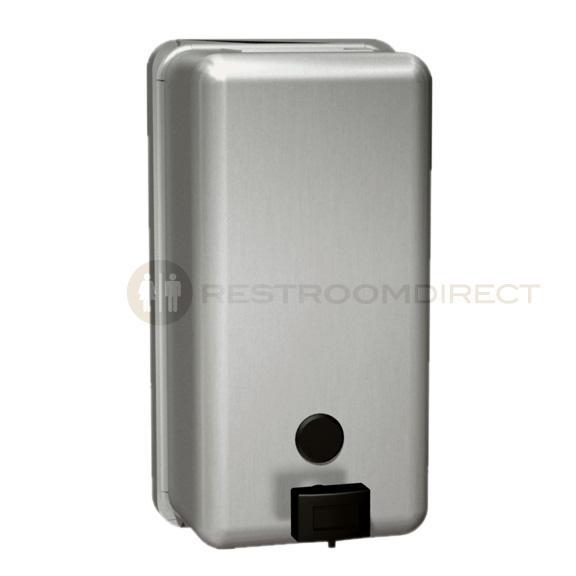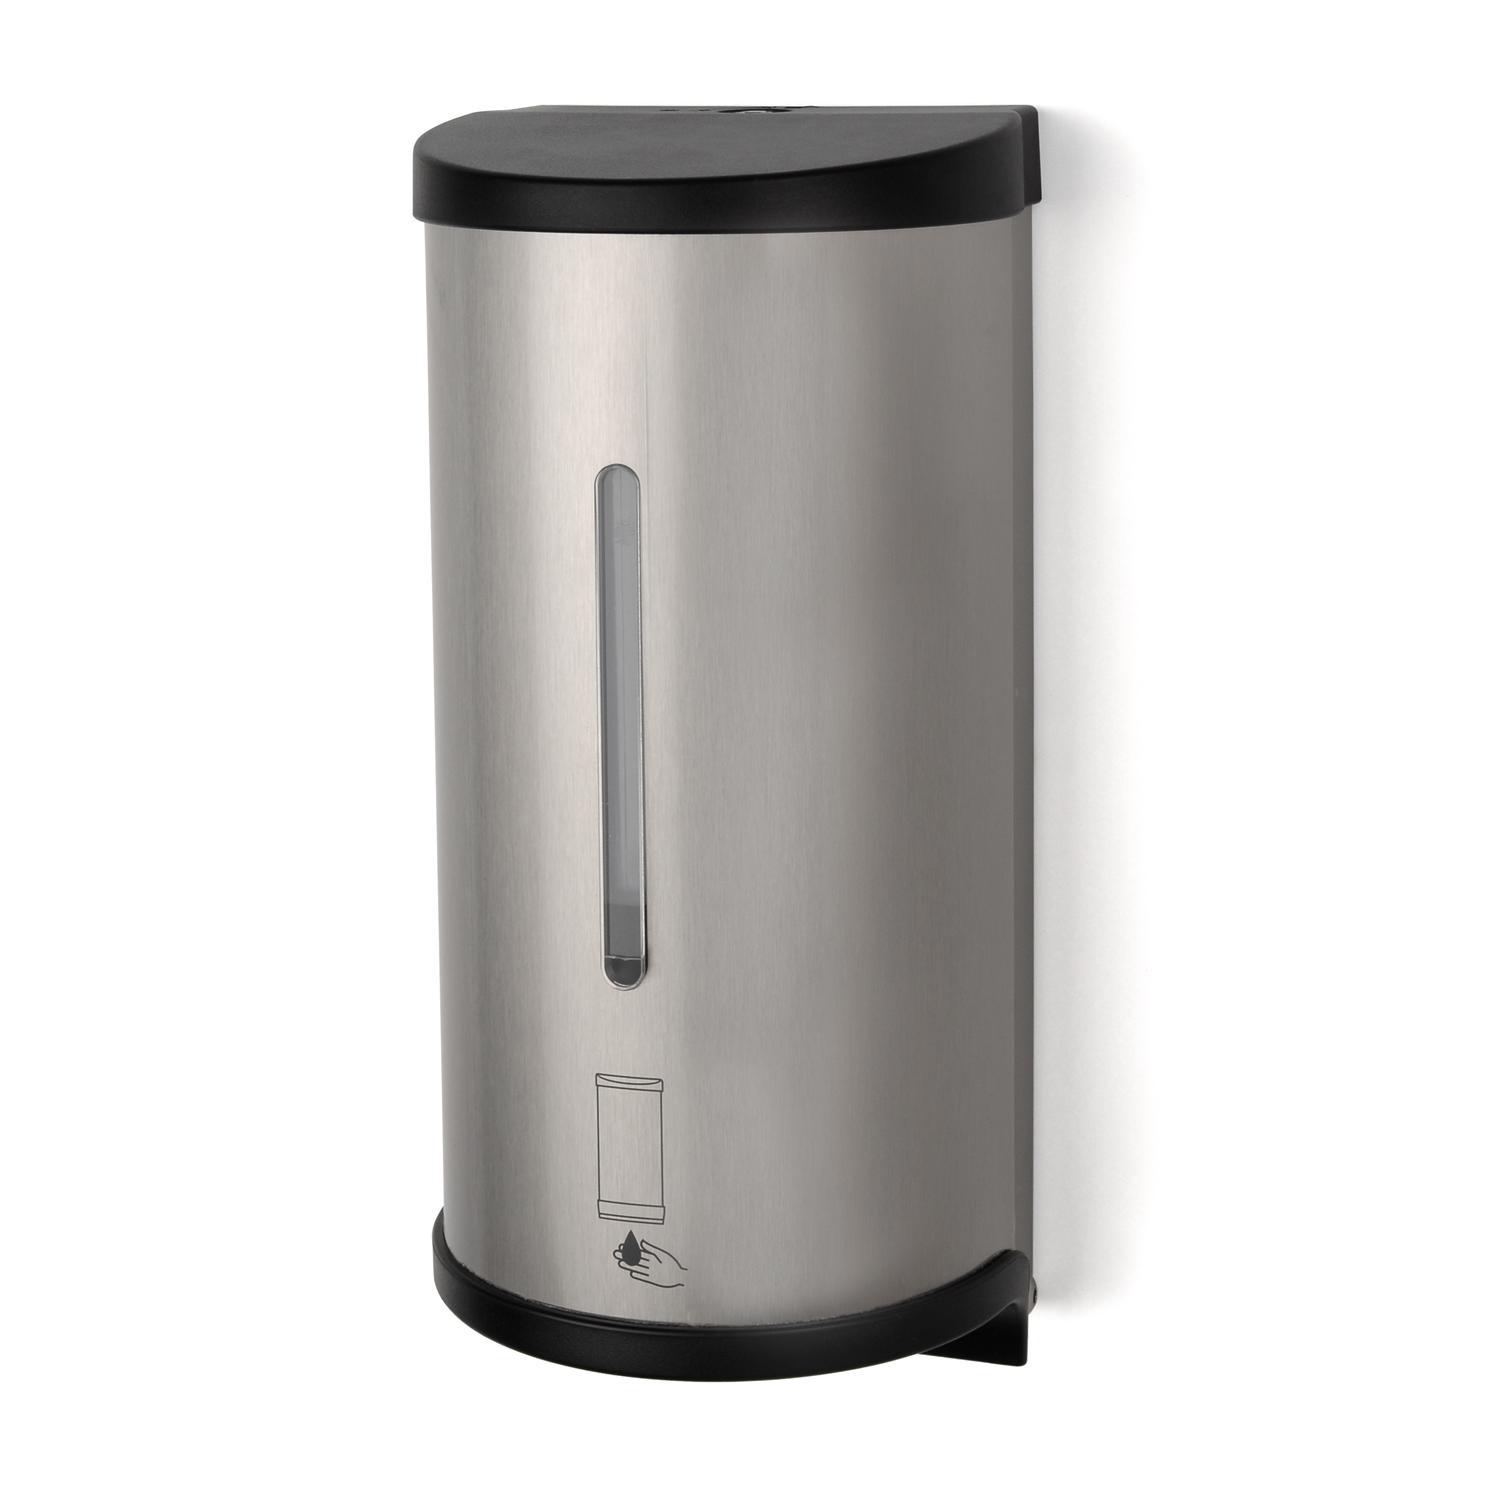The first image is the image on the left, the second image is the image on the right. Analyze the images presented: Is the assertion "The dispenser on the right has a black base." valid? Answer yes or no. Yes. 